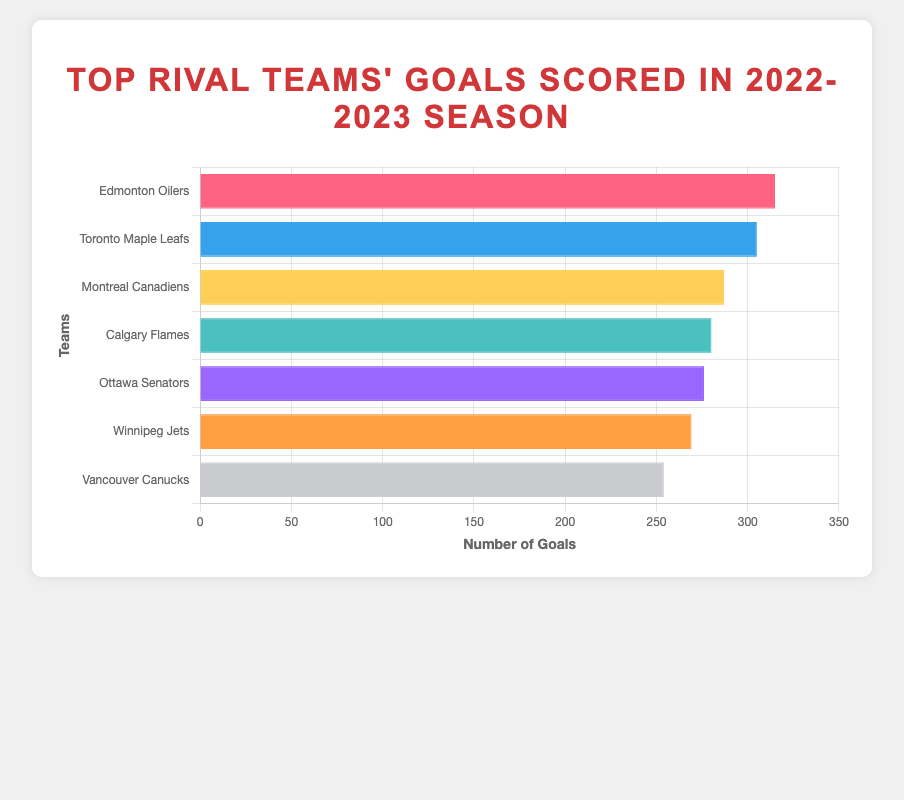Which team scored the most goals in the 2022-2023 season? The horizontal bar chart ranks the teams by the number of goals scored. The Edmonton Oilers appear first with 315 goals, making them the top goal-scoring team.
Answer: Edmonton Oilers Which team scored the fewest goals in the 2022-2023 season? The horizontal bar chart shows the Vancouver Canucks at the bottom with 254 goals, indicating they scored the fewest goals.
Answer: Vancouver Canucks How many more goals did the Edmonton Oilers score compared to the Vancouver Canucks? The bar for the Edmonton Oilers shows 315 goals, while the bar for the Vancouver Canucks shows 254 goals. The difference is 315 - 254.
Answer: 61 What is the total number of goals scored by all teams combined? Adding up the goals from all teams: 315 (Edmonton Oilers) + 305 (Toronto Maple Leafs) + 287 (Montreal Canadiens) + 280 (Calgary Flames) + 276 (Ottawa Senators) + 269 (Winnipeg Jets) + 254 (Vancouver Canucks) = 1986.
Answer: 1986 Which team scored more goals: Montreal Canadiens or Calgary Flames? The bar for the Montreal Canadiens shows 287 goals, and the bar for the Calgary Flames shows 280 goals. Since 287 > 280, the Montreal Canadiens scored more goals.
Answer: Montreal Canadiens What is the average number of goals scored by these teams in the 2022-2023 season? To find the average, sum up all goals scored by the teams and divide by the number of teams. Total goals = 1986. There are 7 teams. Average = 1986 / 7.
Answer: 283.71 How much higher is the number of goals scored by the Toronto Maple Leafs compared to the Winnipeg Jets? The Toronto Maple Leafs scored 305 goals, and the Winnipeg Jets scored 269 goals. The difference is 305 - 269.
Answer: 36 Which teams have scored between 270 and 310 goals? The horizontal bar chart shows that the Toronto Maple Leafs (305), Montreal Canadiens (287), Calgary Flames (280), and Ottawa Senators (276) fall within the 270 to 310 goals range.
Answer: Toronto Maple Leafs, Montreal Canadiens, Calgary Flames, Ottawa Senators What is the combined number of goals scored by the three lowest-scoring teams? The three lowest-scoring teams are Vancouver Canucks (254), Winnipeg Jets (269), and Ottawa Senators (276). Adding these: 254 + 269 + 276 = 799.
Answer: 799 Which teams' bars are colored blue and green on the chart? The color blue represents the Toronto Maple Leafs, while the color green represents the Calgary Flames, as per the colors designated in the chart dataset.
Answer: Toronto Maple Leafs, Calgary Flames 